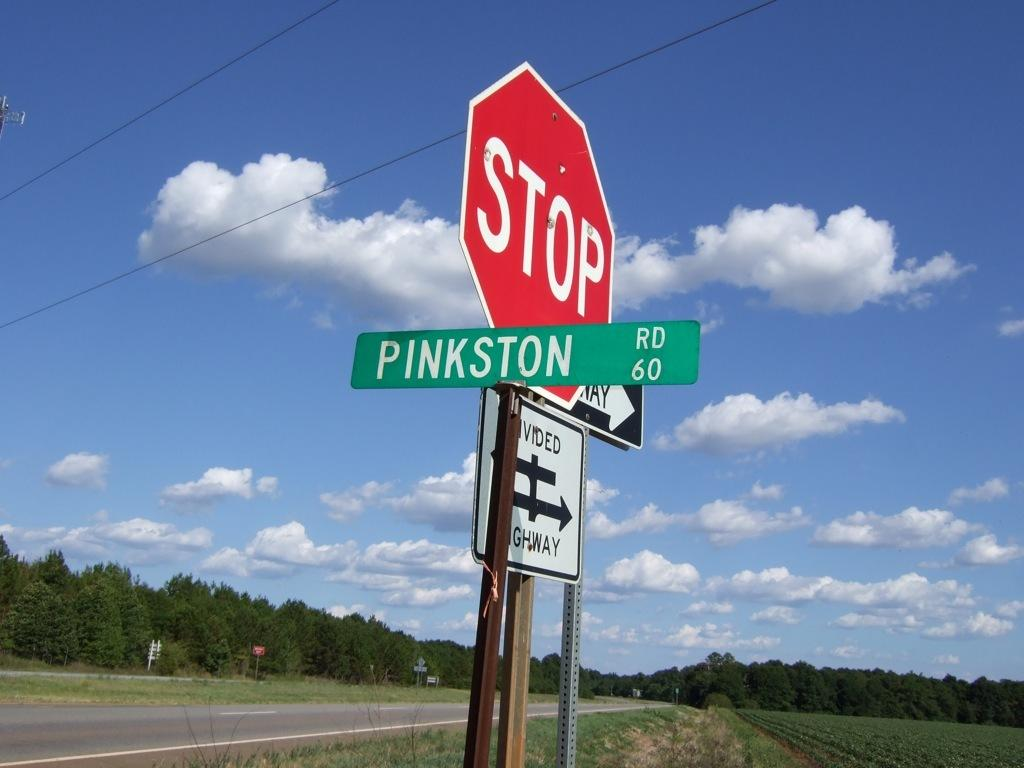Provide a one-sentence caption for the provided image. A sign for Pinkston Road is posted next to a stop sign. 